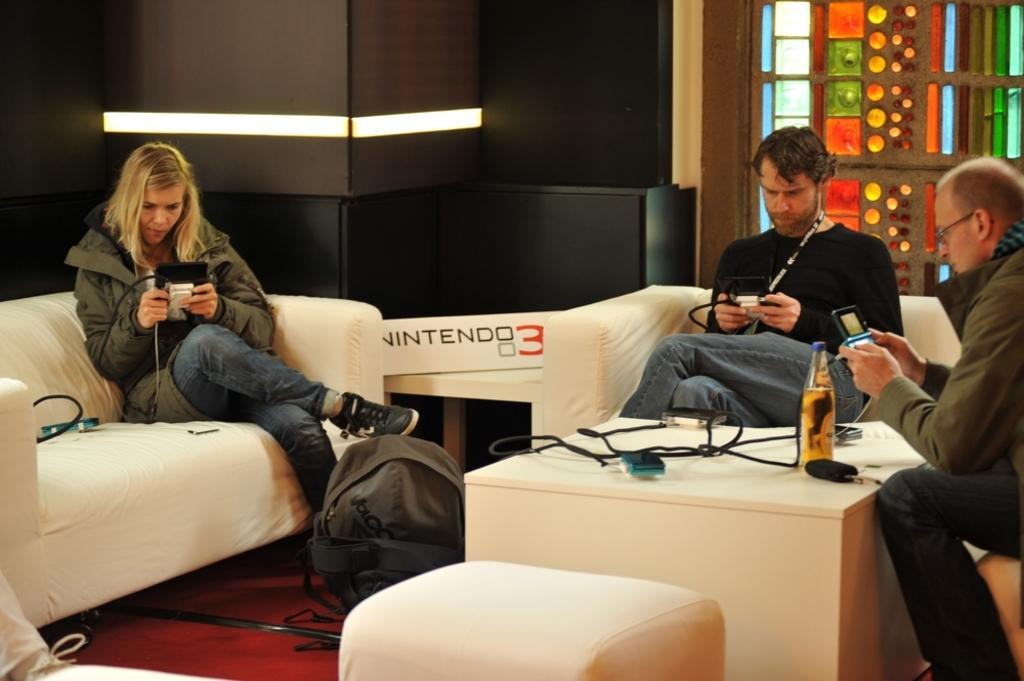How many people are in the image? There are three persons in the image. What are the persons doing in the image? The persons are sitting on sofas. What is located in front of the persons? There is a bag, a table, and a bottle in front of the persons. What are the persons holding in the image? The persons are holding objects. What color are the strangers' eyes in the image? There are no strangers present in the image, and therefore no information about their eyes can be provided. 